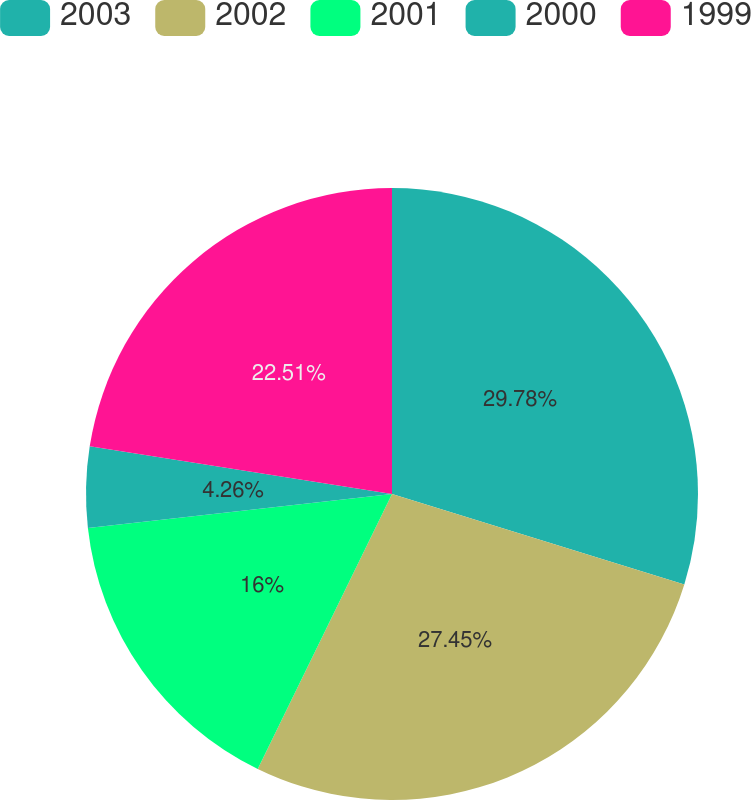<chart> <loc_0><loc_0><loc_500><loc_500><pie_chart><fcel>2003<fcel>2002<fcel>2001<fcel>2000<fcel>1999<nl><fcel>29.78%<fcel>27.45%<fcel>16.0%<fcel>4.26%<fcel>22.51%<nl></chart> 